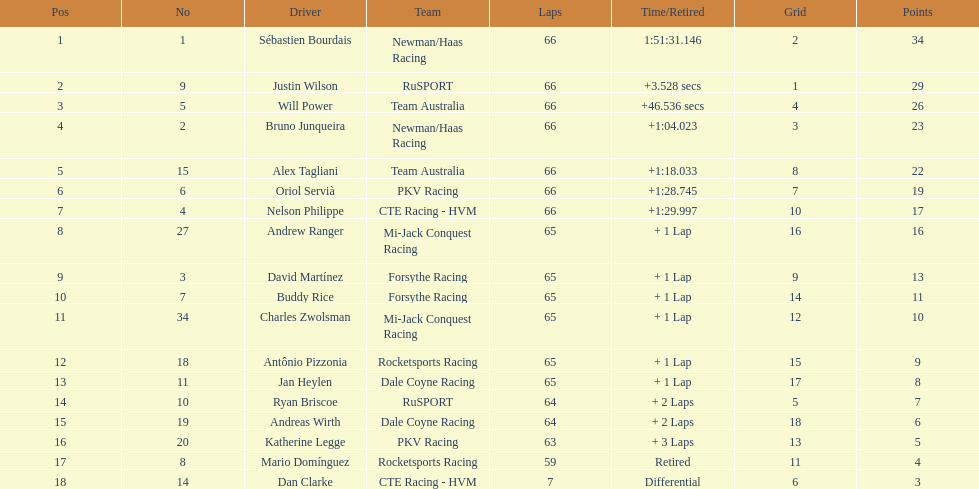At the 2006 gran premio telmex, did oriol servia or katherine legge finish more laps? Oriol Servià. 